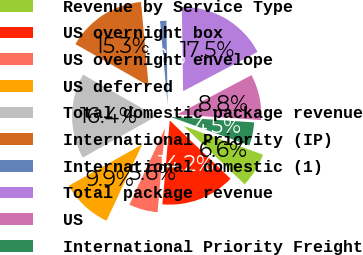<chart> <loc_0><loc_0><loc_500><loc_500><pie_chart><fcel>Revenue by Service Type<fcel>US overnight box<fcel>US overnight envelope<fcel>US deferred<fcel>Total domestic package revenue<fcel>International Priority (IP)<fcel>International domestic (1)<fcel>Total package revenue<fcel>US<fcel>International Priority Freight<nl><fcel>6.63%<fcel>14.24%<fcel>5.55%<fcel>9.89%<fcel>16.41%<fcel>15.32%<fcel>1.2%<fcel>17.5%<fcel>8.8%<fcel>4.46%<nl></chart> 